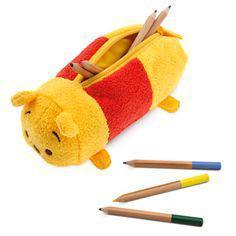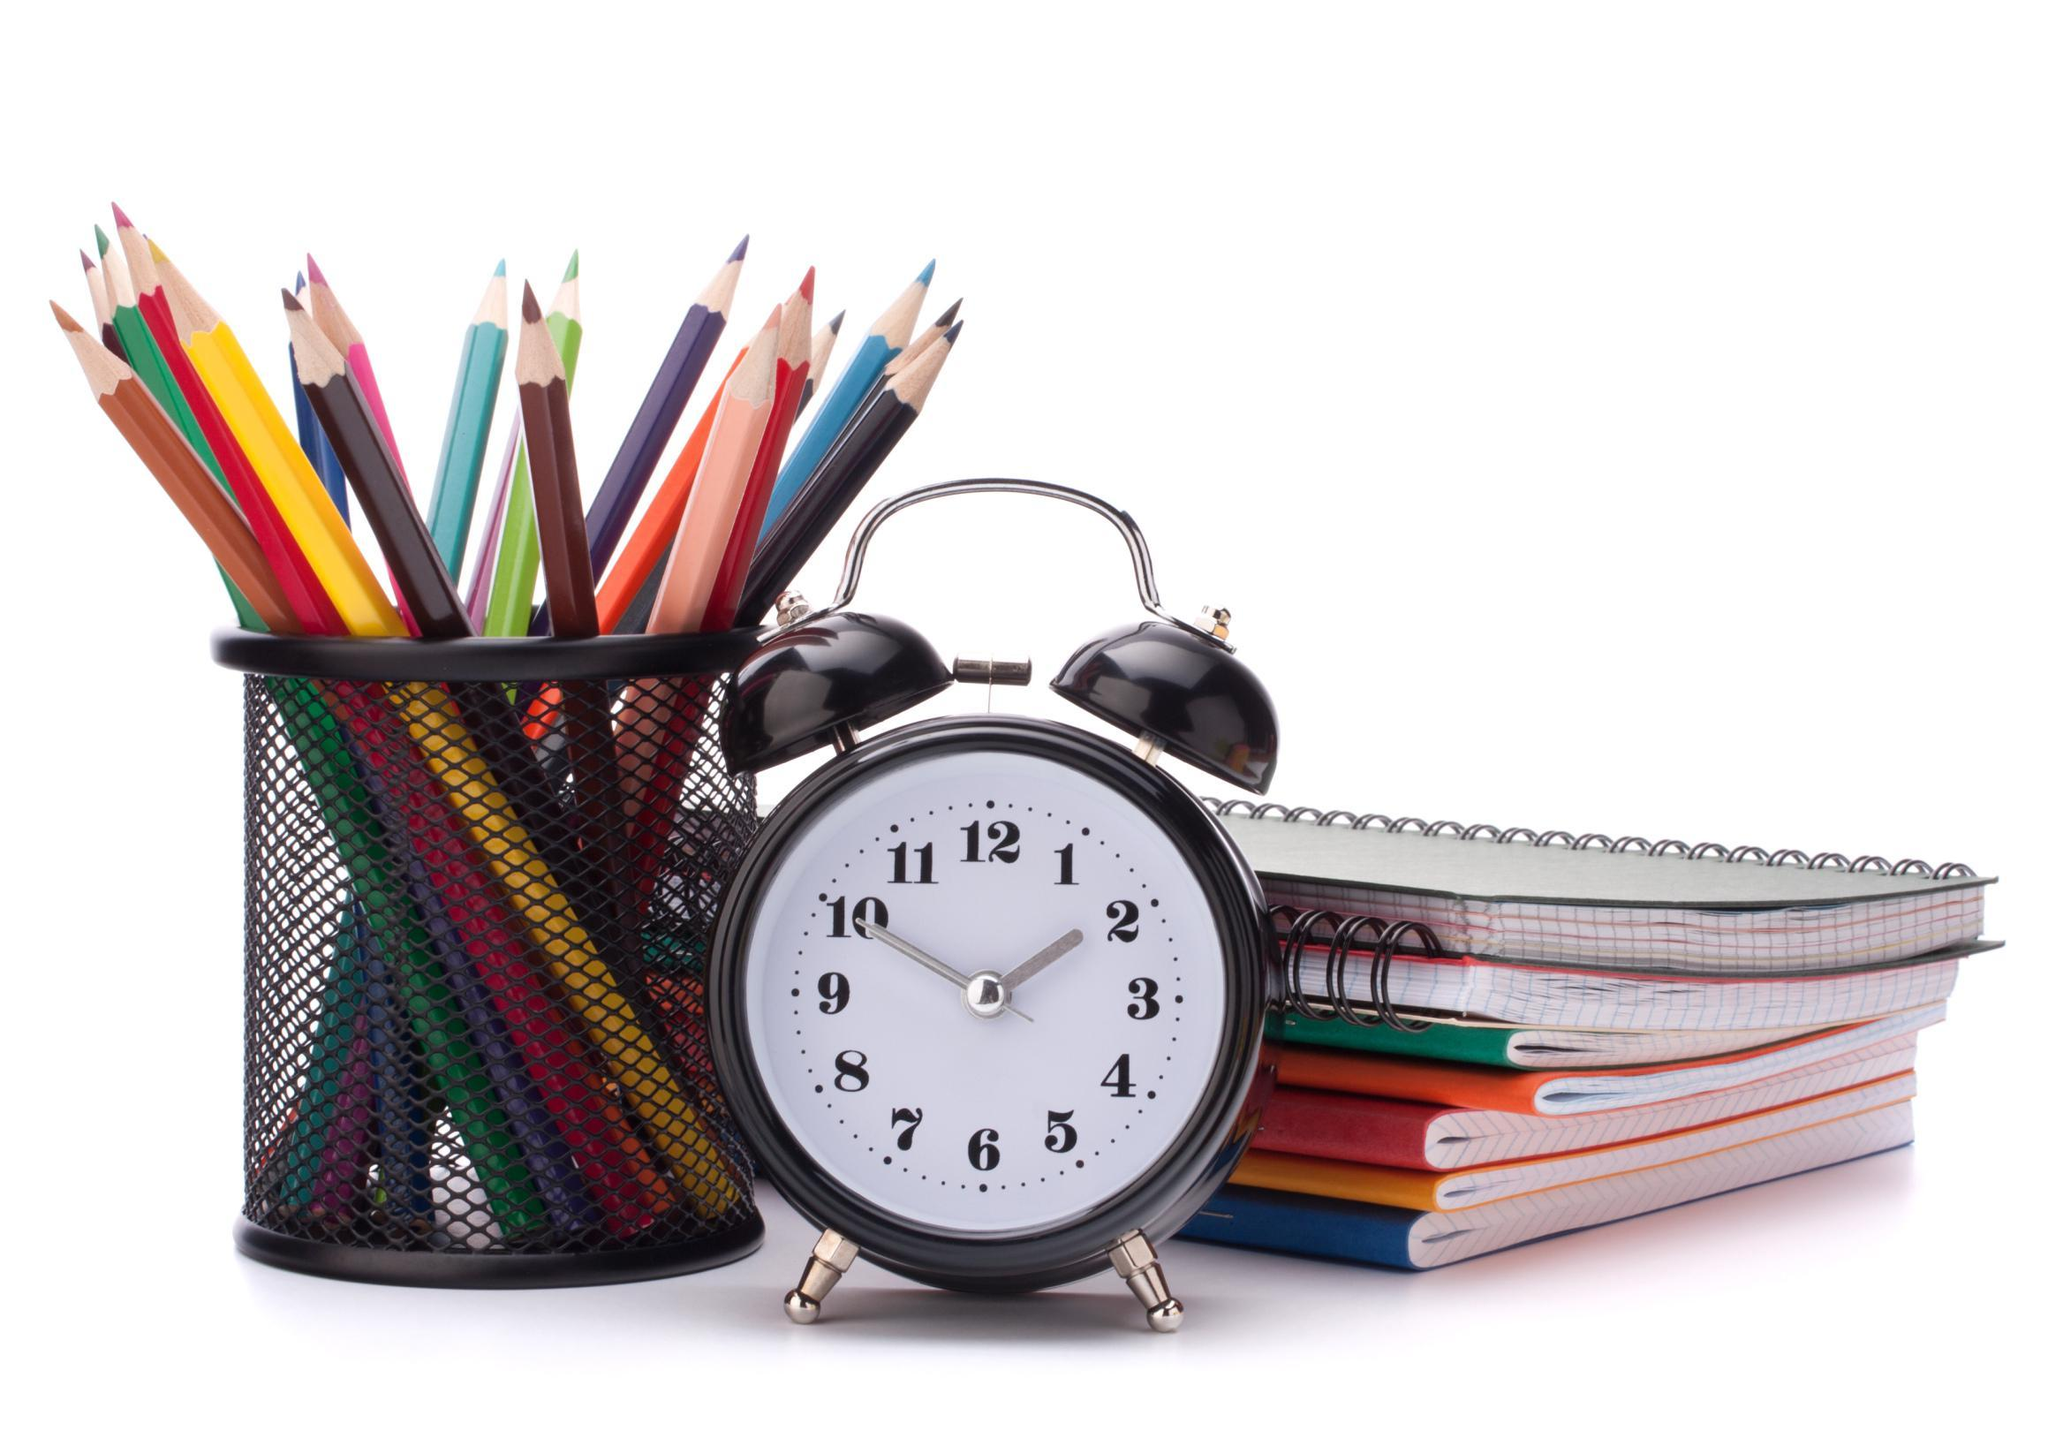The first image is the image on the left, the second image is the image on the right. For the images shown, is this caption "An image contains at least one green pencil bag with a red zipper." true? Answer yes or no. No. The first image is the image on the left, the second image is the image on the right. Considering the images on both sides, is "One image features a pencil case style with red zipper and green and gray color scheme, and the other image includes various rainbow colors on something black." valid? Answer yes or no. No. 